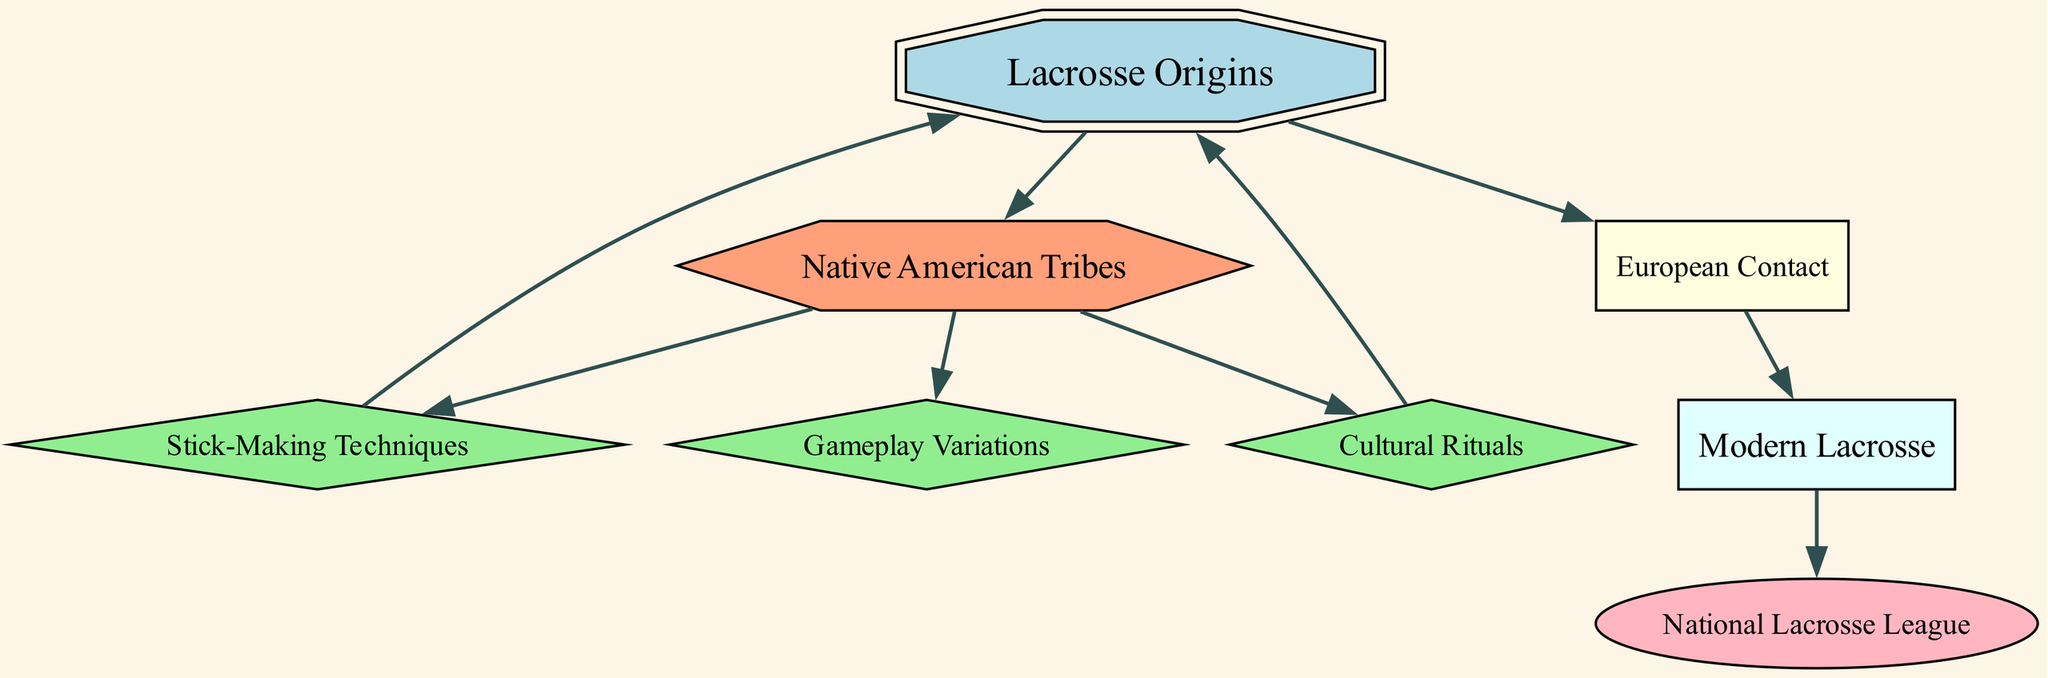What is the total number of nodes in the diagram? The diagram lists eight nodes: Lacrosse Origins, Native American Tribes, Stick-Making Techniques, Cultural Rituals, Gameplay Variations, European Contact, Modern Lacrosse, National Lacrosse League. Counting these, we get eight.
Answer: 8 Which node is connected directly to "Lacrosse Origins"? In the diagram, "Lacrosse Origins" is connected to "Native American Tribes," "European Contact," and "Cultural Rituals." The question specifically asks for the direct connections. The first direct connection is "Native American Tribes."
Answer: Native American Tribes What shape is used for the "Stick-Making Techniques" node? In the diagram, "Stick-Making Techniques" is represented as a diamond shape (as described by the node styles). This categorizes it in a specific manner visually.
Answer: Diamond How many edges originate from "Native American Tribes"? Analyzing the edges that originate from "Native American Tribes," we see three direct edges leading to "Stick-Making Techniques," "Cultural Rituals," and "Gameplay Variations." Each represents a distinct connection in the diagram.
Answer: 3 What is the flow of evolution from "European Contact" to "National Lacrosse League"? The flow begins at "European Contact," which leads to "Modern Lacrosse," and then subsequently to "National Lacrosse League." This demonstrates the progression from earlier influence to contemporary organization.
Answer: European Contact → Modern Lacrosse → National Lacrosse League Which node acts as a foundational element for both "Gameplay Variations" and "Cultural Rituals"? "Native American Tribes" is identified in the diagram as the foundational element that connects to both "Gameplay Variations" and "Cultural Rituals." This indicates the originating influence of these variations within the tribes.
Answer: Native American Tribes How many types of shapes are represented in the diagram? There are four distinct shapes seen in the diagram: double octagon, hexagon, diamond, and box. Each shape categorizes the nodes in a particular way which reflects their significance in lacrosse history.
Answer: 4 What connects "Modern Lacrosse" to "National Lacrosse League"? The only node connecting "Modern Lacrosse" to "National Lacrosse League" is "European Contact," which flows through "Modern Lacrosse" as a precursor to the establishment of the league. This highlights the influence of modern elements on the league structure.
Answer: Modern Lacrosse 